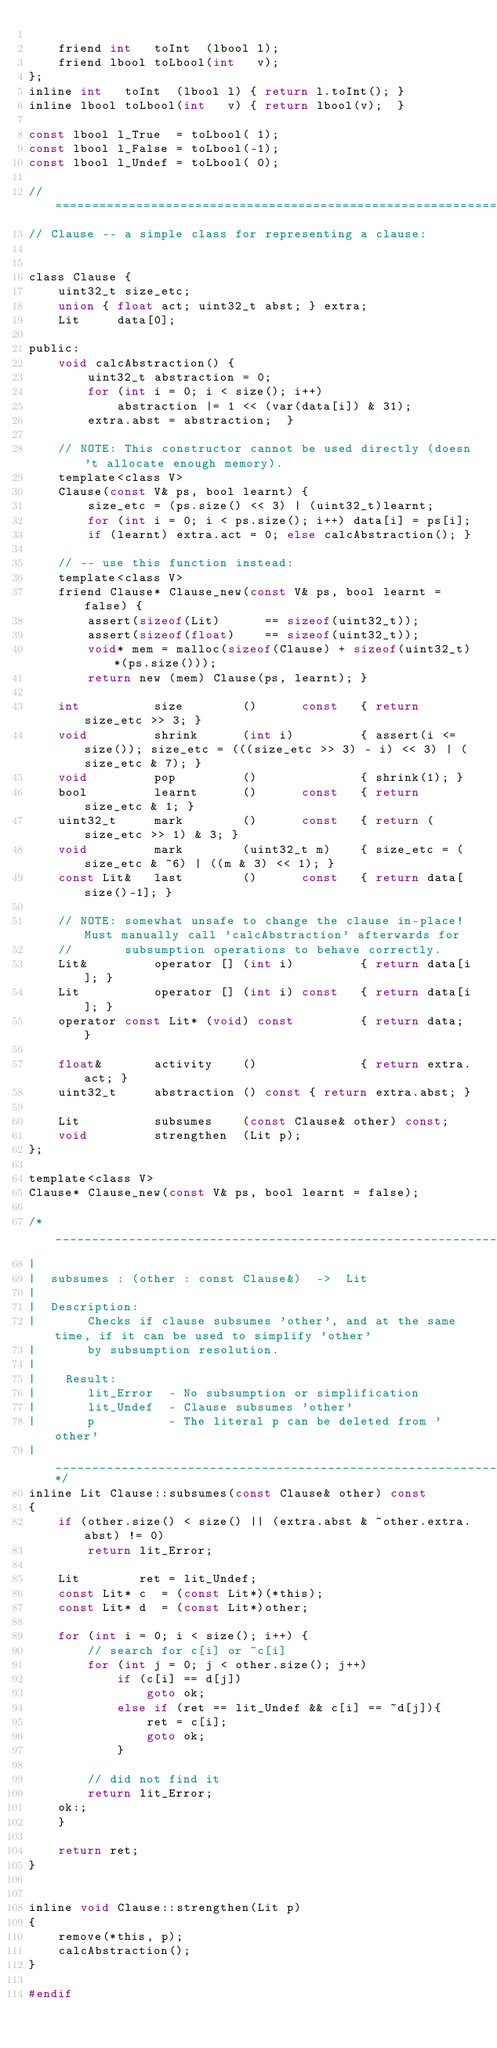Convert code to text. <code><loc_0><loc_0><loc_500><loc_500><_C_>
    friend int   toInt  (lbool l);
    friend lbool toLbool(int   v);
};
inline int   toInt  (lbool l) { return l.toInt(); }
inline lbool toLbool(int   v) { return lbool(v);  }

const lbool l_True  = toLbool( 1);
const lbool l_False = toLbool(-1);
const lbool l_Undef = toLbool( 0);

//=================================================================================================
// Clause -- a simple class for representing a clause:


class Clause {
    uint32_t size_etc;
    union { float act; uint32_t abst; } extra;
    Lit     data[0];

public:
    void calcAbstraction() {
        uint32_t abstraction = 0;
        for (int i = 0; i < size(); i++)
            abstraction |= 1 << (var(data[i]) & 31);
        extra.abst = abstraction;  }

    // NOTE: This constructor cannot be used directly (doesn't allocate enough memory).
    template<class V>
    Clause(const V& ps, bool learnt) {
        size_etc = (ps.size() << 3) | (uint32_t)learnt;
        for (int i = 0; i < ps.size(); i++) data[i] = ps[i];
        if (learnt) extra.act = 0; else calcAbstraction(); }

    // -- use this function instead:
    template<class V>
    friend Clause* Clause_new(const V& ps, bool learnt = false) {
        assert(sizeof(Lit)      == sizeof(uint32_t));
        assert(sizeof(float)    == sizeof(uint32_t));
        void* mem = malloc(sizeof(Clause) + sizeof(uint32_t)*(ps.size()));
        return new (mem) Clause(ps, learnt); }

    int          size        ()      const   { return size_etc >> 3; }
    void         shrink      (int i)         { assert(i <= size()); size_etc = (((size_etc >> 3) - i) << 3) | (size_etc & 7); }
    void         pop         ()              { shrink(1); }
    bool         learnt      ()      const   { return size_etc & 1; }
    uint32_t     mark        ()      const   { return (size_etc >> 1) & 3; }
    void         mark        (uint32_t m)    { size_etc = (size_etc & ~6) | ((m & 3) << 1); }
    const Lit&   last        ()      const   { return data[size()-1]; }

    // NOTE: somewhat unsafe to change the clause in-place! Must manually call 'calcAbstraction' afterwards for
    //       subsumption operations to behave correctly.
    Lit&         operator [] (int i)         { return data[i]; }
    Lit          operator [] (int i) const   { return data[i]; }
    operator const Lit* (void) const         { return data; }

    float&       activity    ()              { return extra.act; }
    uint32_t     abstraction () const { return extra.abst; }

    Lit          subsumes    (const Clause& other) const;
    void         strengthen  (Lit p);
};

template<class V>
Clause* Clause_new(const V& ps, bool learnt = false);

/*_________________________________________________________________________________________________
|
|  subsumes : (other : const Clause&)  ->  Lit
|  
|  Description:
|       Checks if clause subsumes 'other', and at the same time, if it can be used to simplify 'other'
|       by subsumption resolution.
|  
|    Result:
|       lit_Error  - No subsumption or simplification
|       lit_Undef  - Clause subsumes 'other'
|       p          - The literal p can be deleted from 'other'
|________________________________________________________________________________________________@*/
inline Lit Clause::subsumes(const Clause& other) const
{
    if (other.size() < size() || (extra.abst & ~other.extra.abst) != 0)
        return lit_Error;

    Lit        ret = lit_Undef;
    const Lit* c  = (const Lit*)(*this);
    const Lit* d  = (const Lit*)other;

    for (int i = 0; i < size(); i++) {
        // search for c[i] or ~c[i]
        for (int j = 0; j < other.size(); j++)
            if (c[i] == d[j])
                goto ok;
            else if (ret == lit_Undef && c[i] == ~d[j]){
                ret = c[i];
                goto ok;
            }

        // did not find it
        return lit_Error;
    ok:;
    }

    return ret;
}


inline void Clause::strengthen(Lit p)
{
    remove(*this, p);
    calcAbstraction();
}

#endif
</code> 